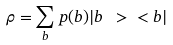<formula> <loc_0><loc_0><loc_500><loc_500>\rho = \sum _ { b } p ( b ) | b \ > \ < b |</formula> 